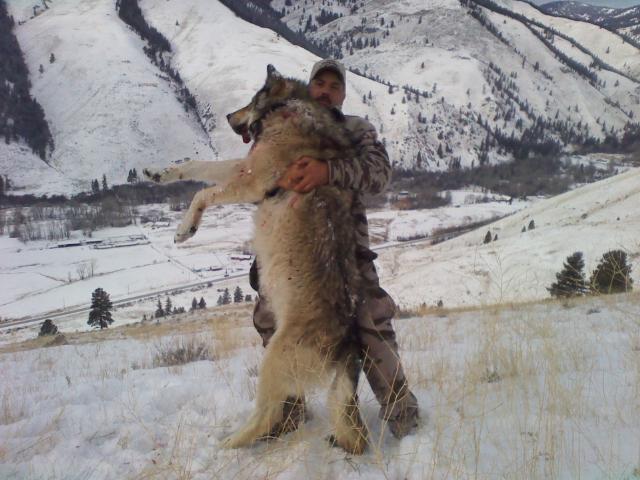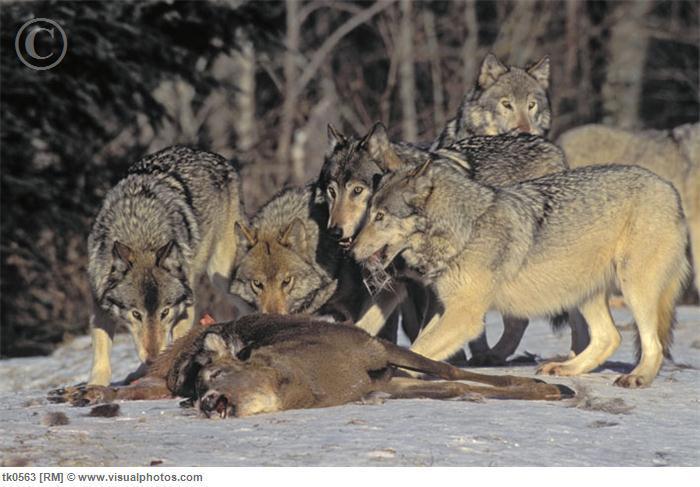The first image is the image on the left, the second image is the image on the right. Evaluate the accuracy of this statement regarding the images: "wolves are feasting on a carcass". Is it true? Answer yes or no. Yes. 